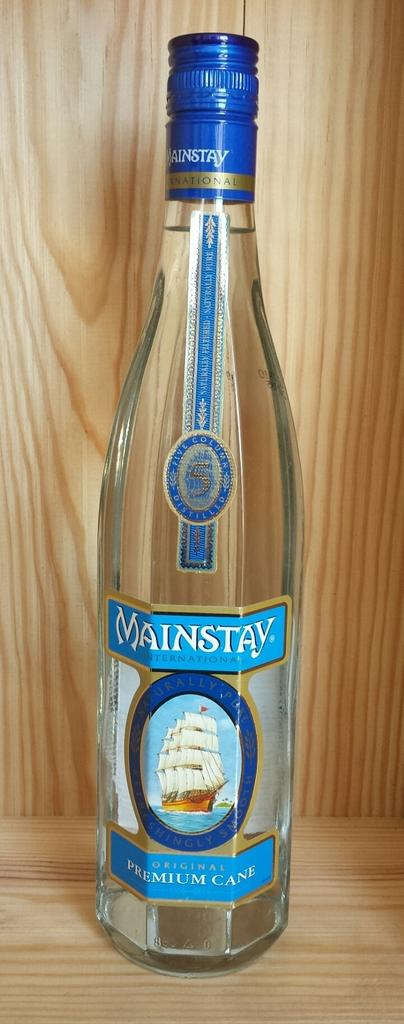What object can be seen in the image? There is a bottle in the image. What information is provided on the bottle? The bottle is labeled as "mainstay." What type of rice is being advertised in the image? There is no rice present in the image; it only features a bottle labeled as "mainstay." 